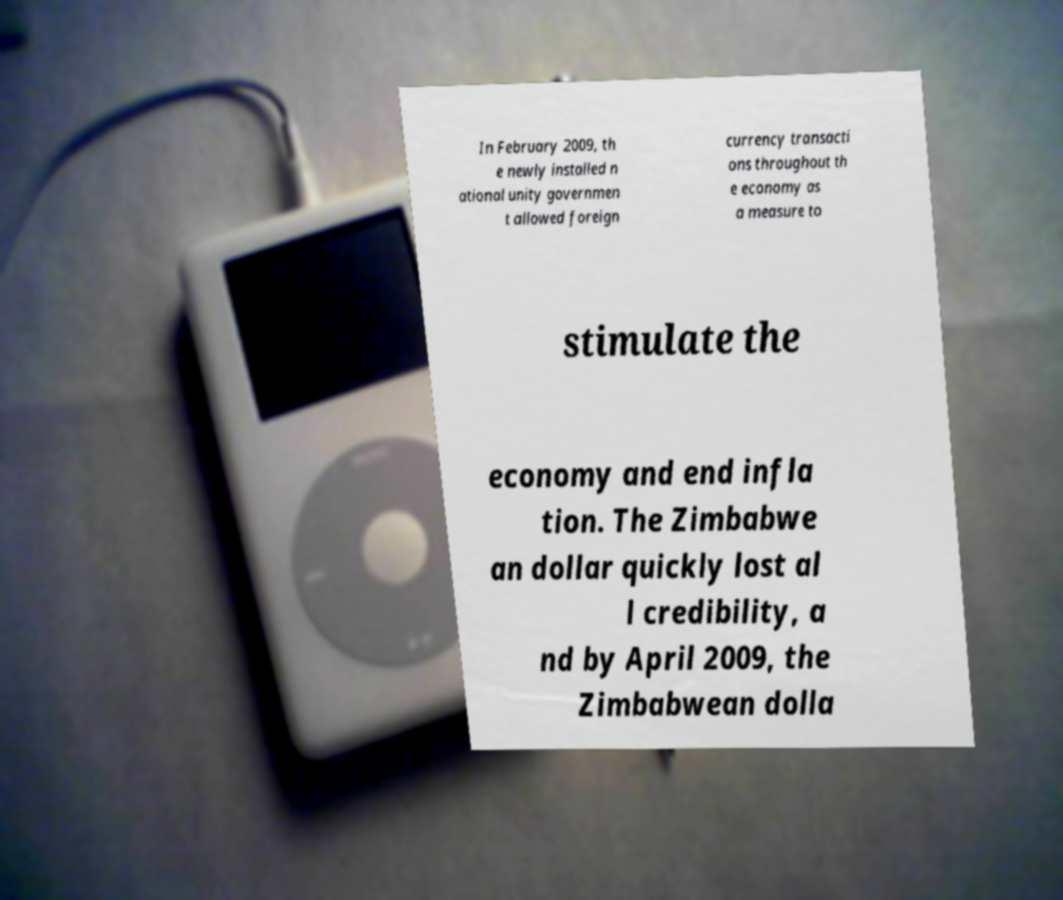There's text embedded in this image that I need extracted. Can you transcribe it verbatim? In February 2009, th e newly installed n ational unity governmen t allowed foreign currency transacti ons throughout th e economy as a measure to stimulate the economy and end infla tion. The Zimbabwe an dollar quickly lost al l credibility, a nd by April 2009, the Zimbabwean dolla 